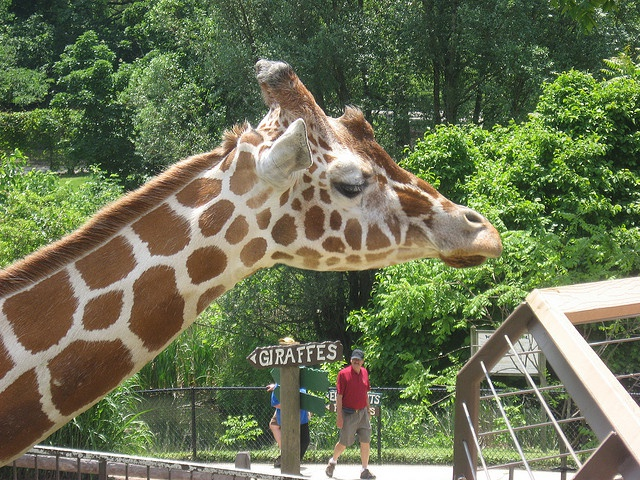Describe the objects in this image and their specific colors. I can see giraffe in black, maroon, darkgray, and gray tones, people in black, gray, maroon, and brown tones, people in black, blue, and gray tones, and people in black, gray, tan, and darkgray tones in this image. 